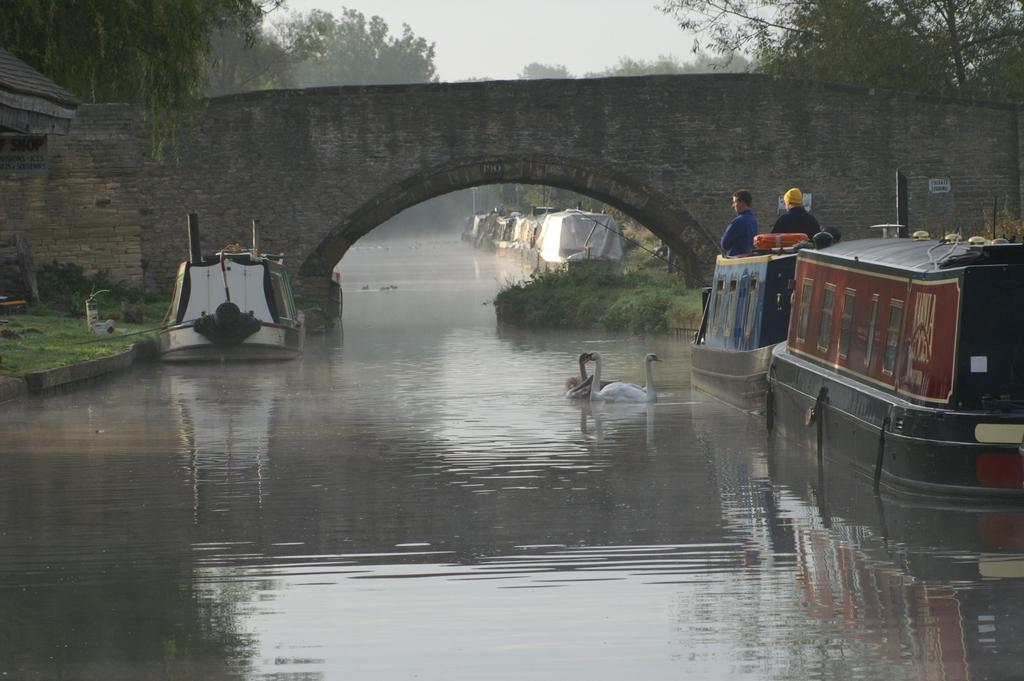How would you summarize this image in a sentence or two? In this image we can see people, arch, ducks, boats, trees, water and we can also see the sky. 